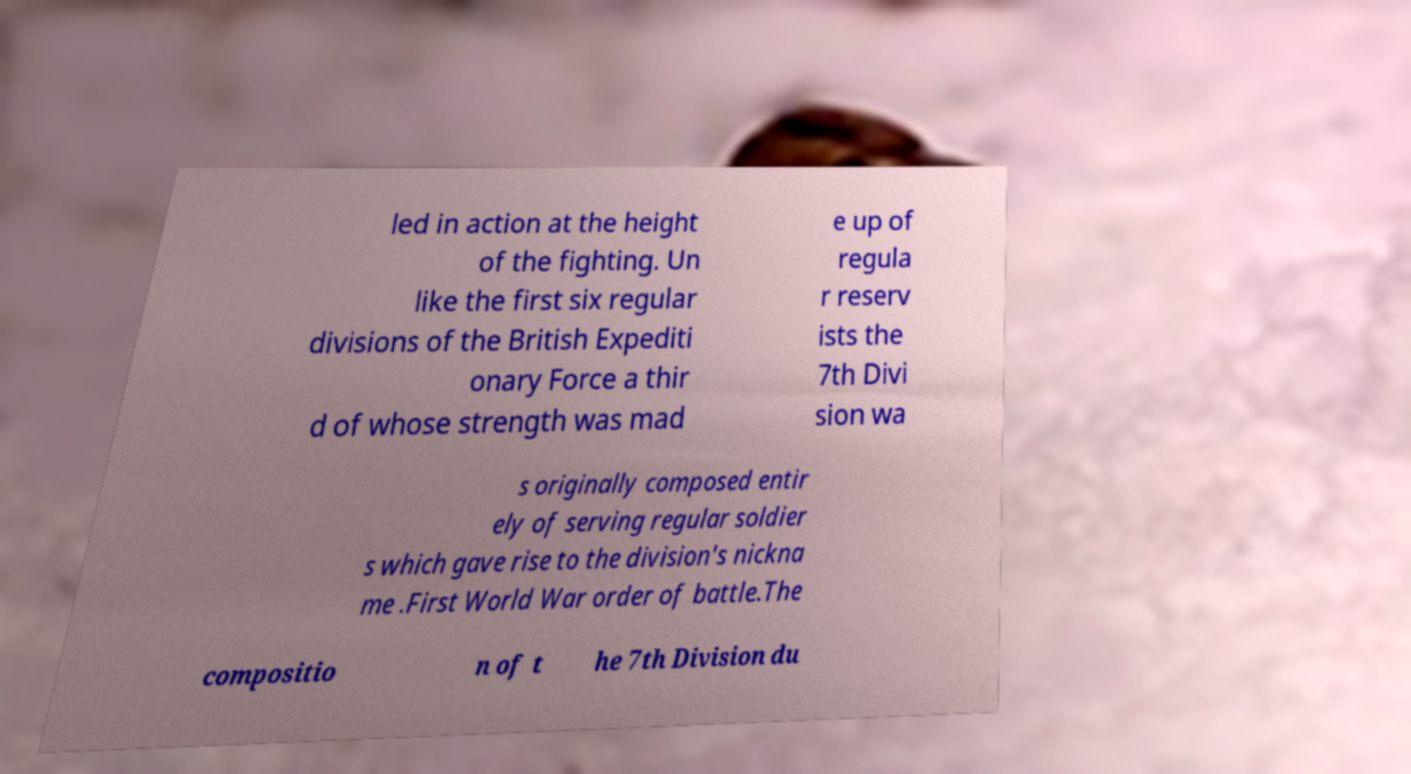Could you assist in decoding the text presented in this image and type it out clearly? led in action at the height of the fighting. Un like the first six regular divisions of the British Expediti onary Force a thir d of whose strength was mad e up of regula r reserv ists the 7th Divi sion wa s originally composed entir ely of serving regular soldier s which gave rise to the division's nickna me .First World War order of battle.The compositio n of t he 7th Division du 